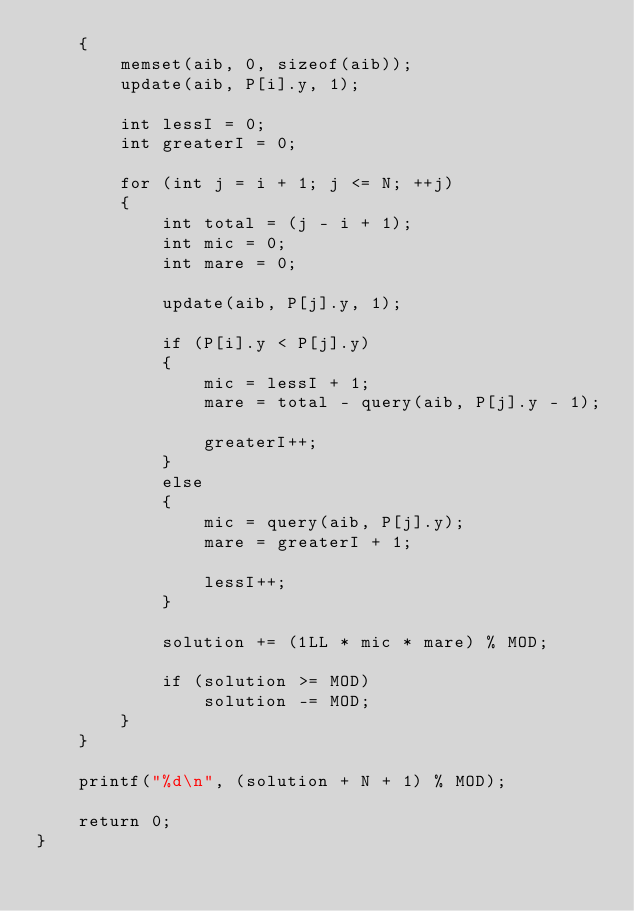Convert code to text. <code><loc_0><loc_0><loc_500><loc_500><_C++_>    {
        memset(aib, 0, sizeof(aib));
        update(aib, P[i].y, 1);

        int lessI = 0;
        int greaterI = 0;

        for (int j = i + 1; j <= N; ++j)
        {
            int total = (j - i + 1);
            int mic = 0;
            int mare = 0;

            update(aib, P[j].y, 1);

            if (P[i].y < P[j].y)
            {
                mic = lessI + 1;
                mare = total - query(aib, P[j].y - 1);

                greaterI++;
            }
            else
            {
                mic = query(aib, P[j].y);
                mare = greaterI + 1;

                lessI++;
            }

            solution += (1LL * mic * mare) % MOD;

            if (solution >= MOD)
                solution -= MOD;
        }
    }

    printf("%d\n", (solution + N + 1) % MOD);

    return 0;
}
</code> 